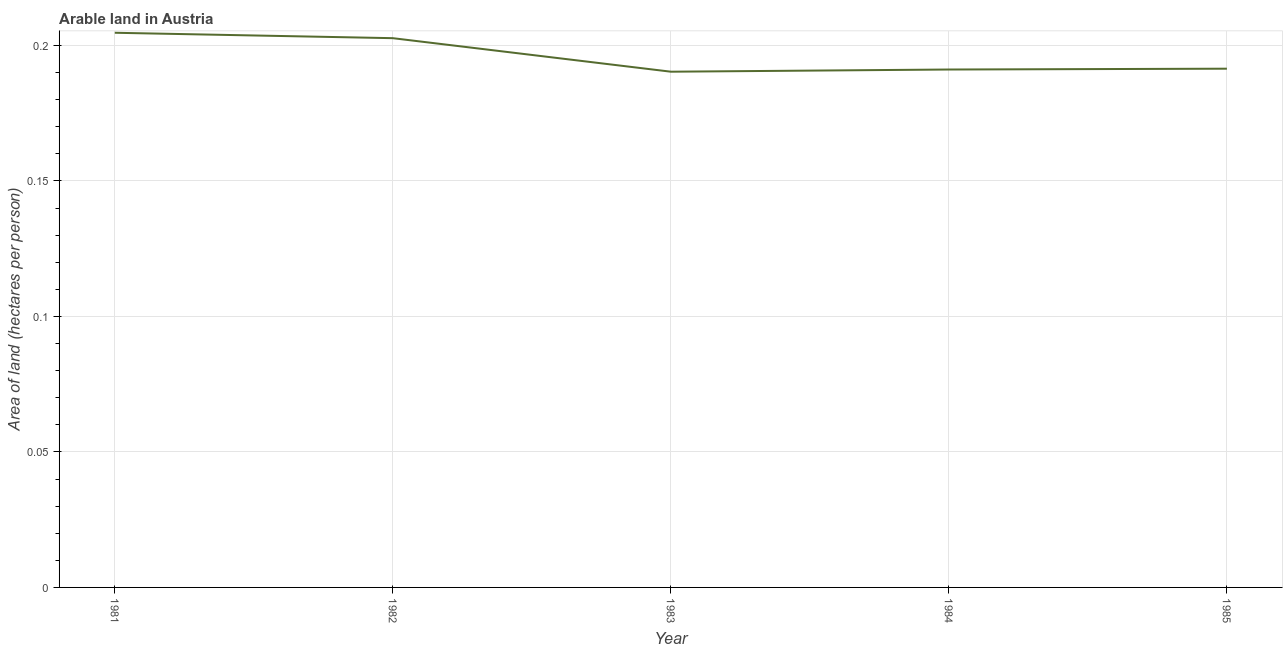What is the area of arable land in 1985?
Ensure brevity in your answer.  0.19. Across all years, what is the maximum area of arable land?
Offer a very short reply. 0.2. Across all years, what is the minimum area of arable land?
Provide a short and direct response. 0.19. In which year was the area of arable land maximum?
Make the answer very short. 1981. What is the sum of the area of arable land?
Keep it short and to the point. 0.98. What is the difference between the area of arable land in 1983 and 1985?
Provide a short and direct response. -0. What is the average area of arable land per year?
Your answer should be very brief. 0.2. What is the median area of arable land?
Your answer should be compact. 0.19. In how many years, is the area of arable land greater than 0.16000000000000003 hectares per person?
Give a very brief answer. 5. What is the ratio of the area of arable land in 1982 to that in 1985?
Your response must be concise. 1.06. Is the area of arable land in 1981 less than that in 1982?
Provide a succinct answer. No. What is the difference between the highest and the second highest area of arable land?
Your answer should be very brief. 0. What is the difference between the highest and the lowest area of arable land?
Provide a succinct answer. 0.01. Does the area of arable land monotonically increase over the years?
Provide a short and direct response. No. Does the graph contain any zero values?
Keep it short and to the point. No. Does the graph contain grids?
Your response must be concise. Yes. What is the title of the graph?
Offer a terse response. Arable land in Austria. What is the label or title of the Y-axis?
Make the answer very short. Area of land (hectares per person). What is the Area of land (hectares per person) in 1981?
Provide a succinct answer. 0.2. What is the Area of land (hectares per person) of 1982?
Your answer should be compact. 0.2. What is the Area of land (hectares per person) in 1983?
Give a very brief answer. 0.19. What is the Area of land (hectares per person) in 1984?
Provide a succinct answer. 0.19. What is the Area of land (hectares per person) of 1985?
Make the answer very short. 0.19. What is the difference between the Area of land (hectares per person) in 1981 and 1982?
Offer a very short reply. 0. What is the difference between the Area of land (hectares per person) in 1981 and 1983?
Your response must be concise. 0.01. What is the difference between the Area of land (hectares per person) in 1981 and 1984?
Your answer should be very brief. 0.01. What is the difference between the Area of land (hectares per person) in 1981 and 1985?
Keep it short and to the point. 0.01. What is the difference between the Area of land (hectares per person) in 1982 and 1983?
Make the answer very short. 0.01. What is the difference between the Area of land (hectares per person) in 1982 and 1984?
Keep it short and to the point. 0.01. What is the difference between the Area of land (hectares per person) in 1982 and 1985?
Your response must be concise. 0.01. What is the difference between the Area of land (hectares per person) in 1983 and 1984?
Keep it short and to the point. -0. What is the difference between the Area of land (hectares per person) in 1983 and 1985?
Your response must be concise. -0. What is the difference between the Area of land (hectares per person) in 1984 and 1985?
Your answer should be compact. -0. What is the ratio of the Area of land (hectares per person) in 1981 to that in 1982?
Make the answer very short. 1.01. What is the ratio of the Area of land (hectares per person) in 1981 to that in 1983?
Make the answer very short. 1.07. What is the ratio of the Area of land (hectares per person) in 1981 to that in 1984?
Ensure brevity in your answer.  1.07. What is the ratio of the Area of land (hectares per person) in 1981 to that in 1985?
Offer a very short reply. 1.07. What is the ratio of the Area of land (hectares per person) in 1982 to that in 1983?
Keep it short and to the point. 1.06. What is the ratio of the Area of land (hectares per person) in 1982 to that in 1984?
Your answer should be compact. 1.06. What is the ratio of the Area of land (hectares per person) in 1982 to that in 1985?
Ensure brevity in your answer.  1.06. What is the ratio of the Area of land (hectares per person) in 1983 to that in 1984?
Make the answer very short. 1. 